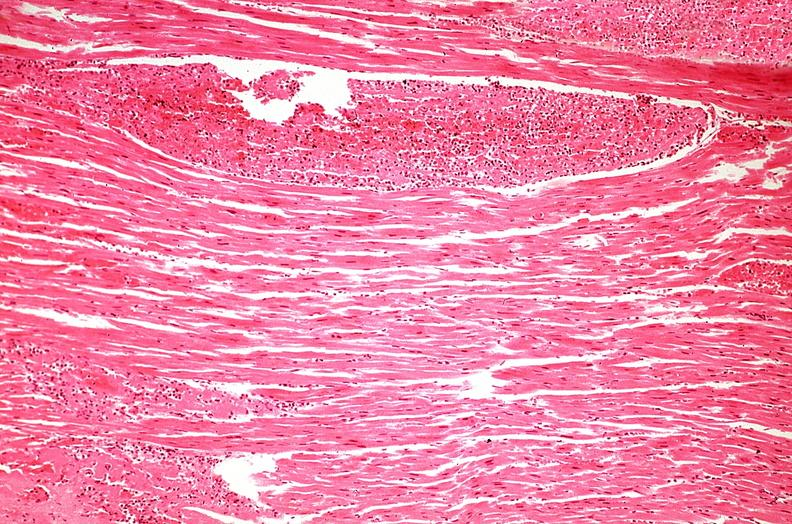what is present?
Answer the question using a single word or phrase. Cardiovascular 